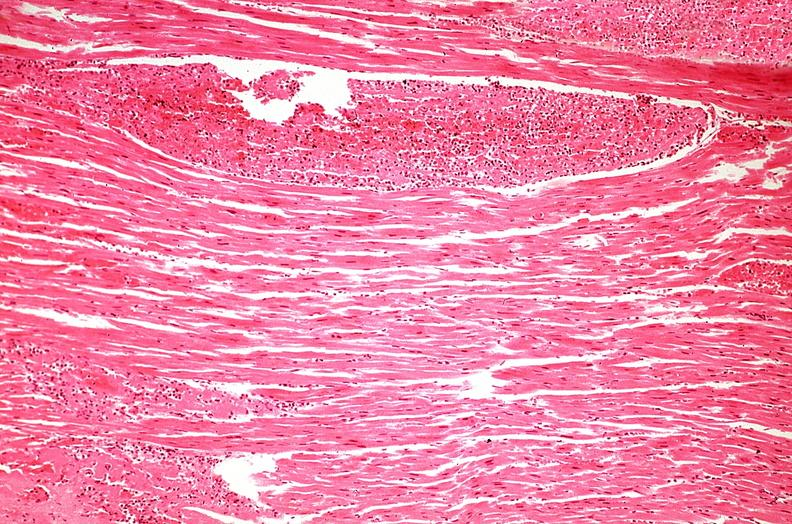what is present?
Answer the question using a single word or phrase. Cardiovascular 